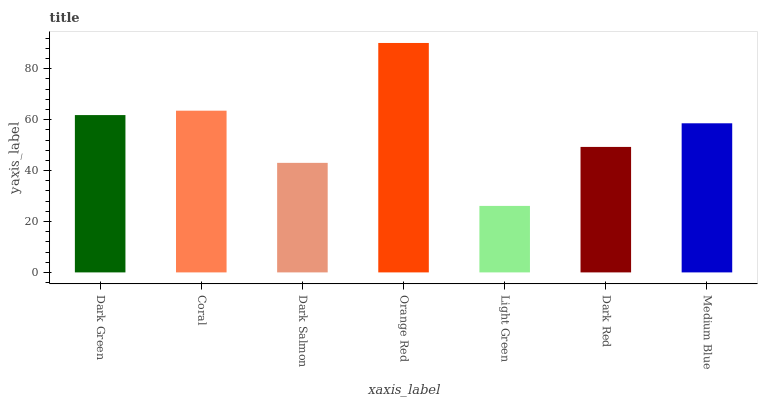Is Light Green the minimum?
Answer yes or no. Yes. Is Orange Red the maximum?
Answer yes or no. Yes. Is Coral the minimum?
Answer yes or no. No. Is Coral the maximum?
Answer yes or no. No. Is Coral greater than Dark Green?
Answer yes or no. Yes. Is Dark Green less than Coral?
Answer yes or no. Yes. Is Dark Green greater than Coral?
Answer yes or no. No. Is Coral less than Dark Green?
Answer yes or no. No. Is Medium Blue the high median?
Answer yes or no. Yes. Is Medium Blue the low median?
Answer yes or no. Yes. Is Dark Salmon the high median?
Answer yes or no. No. Is Light Green the low median?
Answer yes or no. No. 